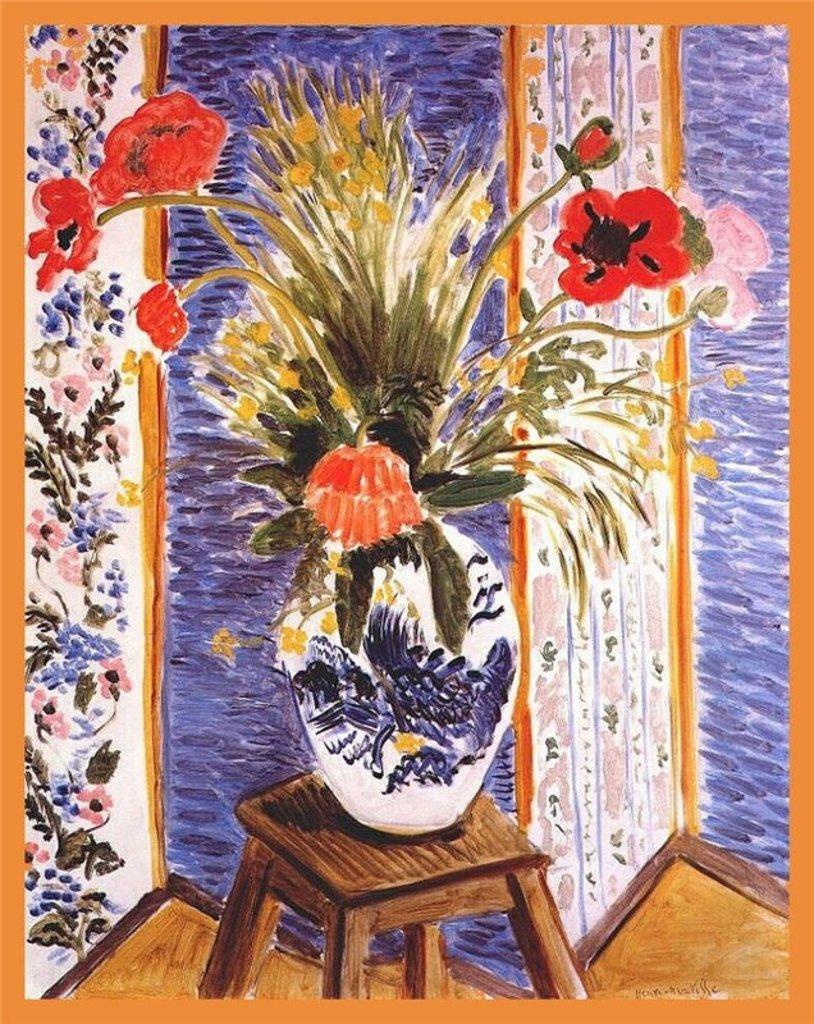Describe this image in one or two sentences. In this picture we can see painting of flowers and leaves in a vase and we can see stool. 